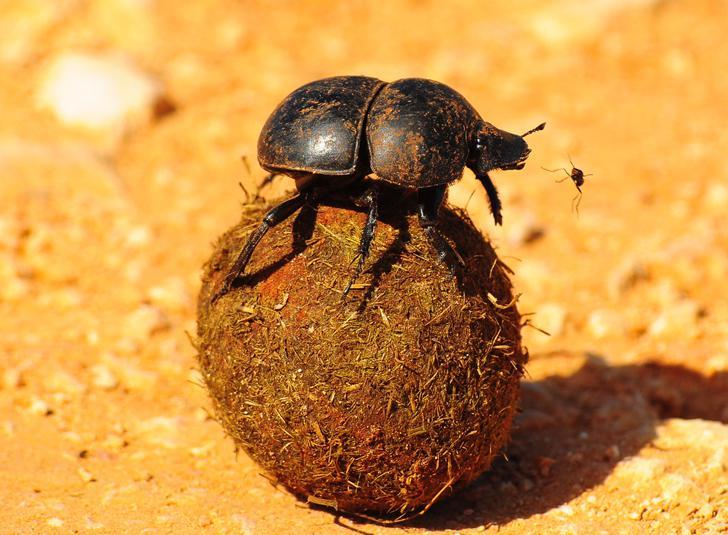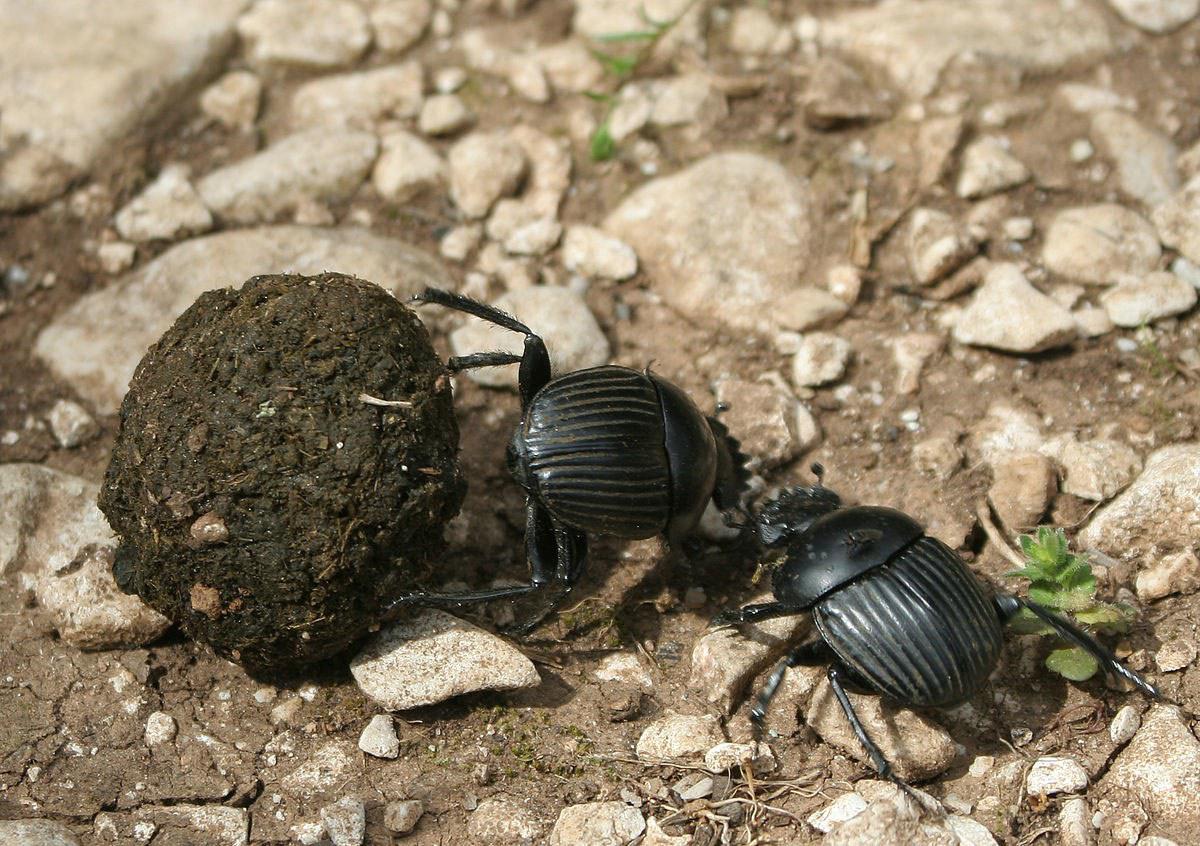The first image is the image on the left, the second image is the image on the right. Evaluate the accuracy of this statement regarding the images: "A beetle is on a dung ball.". Is it true? Answer yes or no. Yes. The first image is the image on the left, the second image is the image on the right. Assess this claim about the two images: "Each image includes a beetle in contact with a round dung ball.". Correct or not? Answer yes or no. Yes. 